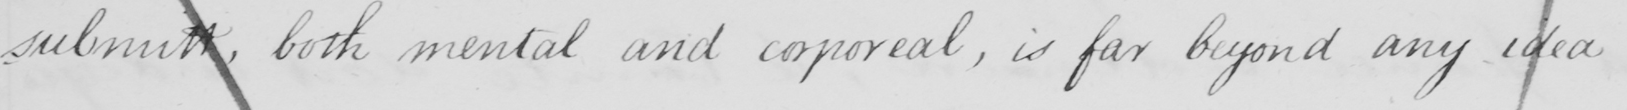Please provide the text content of this handwritten line. submitt, both mental and corporeal, is far beyond any idea 